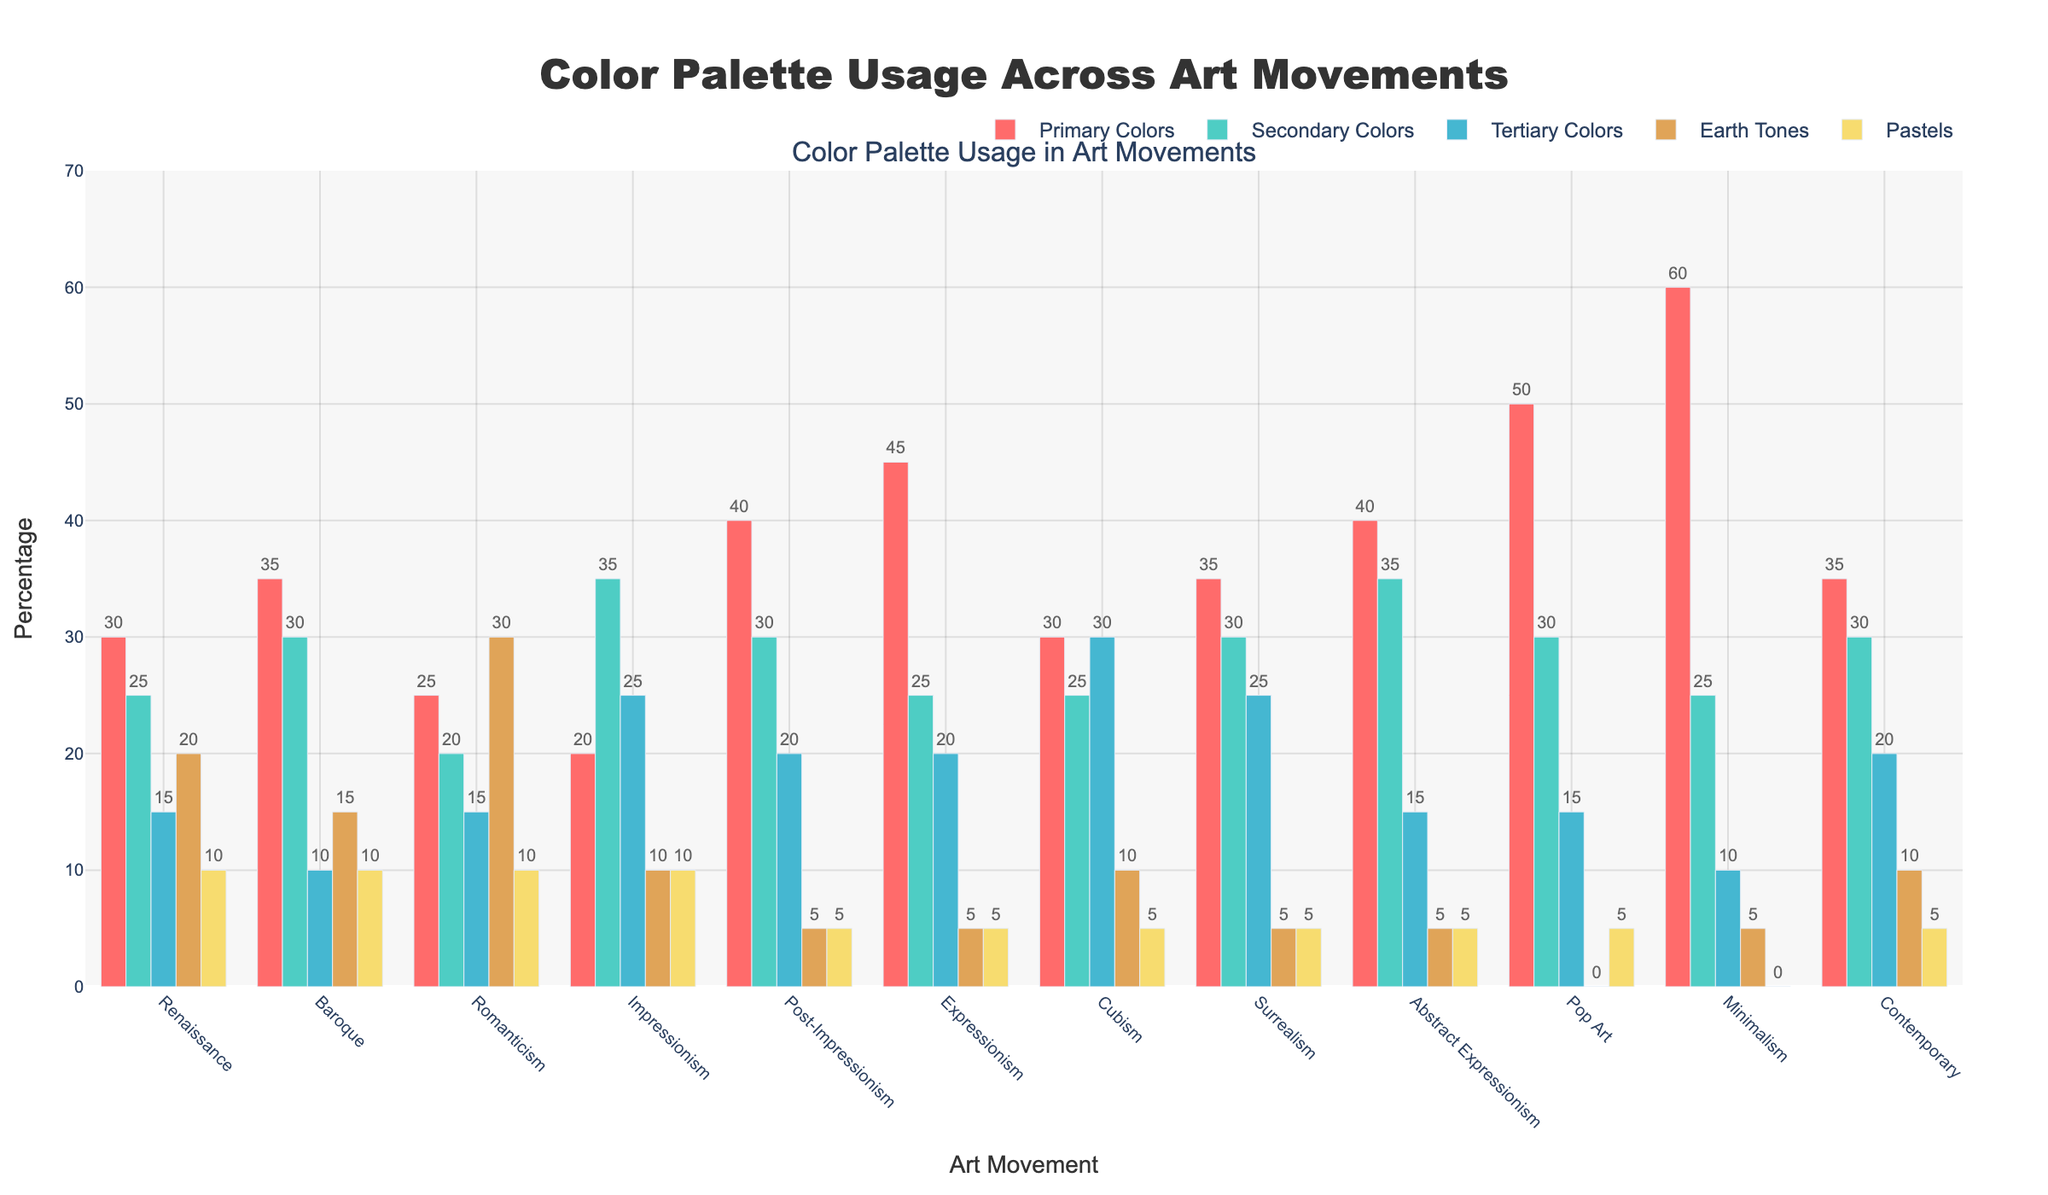Which art movement has the highest use of Primary Colors? The bar for Primary Colors under Minimalism is the tallest among all the art movements.
Answer: Minimalism How does the use of Pastels in Renaissance compare to Pop Art? The bar for Pastels in Renaissance is higher than the bar for Pastels in Pop Art, indicating that Renaissance has a higher usage of Pastels than Pop Art.
Answer: Renaissance What is the sum of Primary Colors and Secondary Colors in Abstract Expressionism? For Abstract Expressionism, Primary Colors is 40 and Secondary Colors is 35. The sum is 40 + 35.
Answer: 75 Which color category shows the least usage in Expressionism? Tertiary Colors, Earth Tones, and Pastels have the shortest bars under Expressionism, and since all three are the same height, any of these can be an answer.
Answer: Tertiary Colors, Earth Tones, Pastels Is the use of Secondary Colors higher in Baroque or Impressionism? The bar for Secondary Colors in Impressionism is higher than that in Baroque.
Answer: Impressionism What is the difference in the use of Earth Tones between Romanticism and Surrealism? Earth Tones in Romanticism is 30 while in Surrealism it is 5. The difference is 30 - 5.
Answer: 25 Which color category is consistently low (5% or under) across most art movements? Pastels appear consistently at or below 5% in several art movements such as Post-Impressionism, Expressionism, Cubism, Surrealism, Abstract Expressionism, Pop Art, and Contemporary.
Answer: Pastels Which art movements have an equal percentage of Secondary Colors usage? The bars for Secondary Colors in Baroque and Post-Impressionism are at the same height, both representing 30%.
Answer: Baroque and Post-Impressionism 